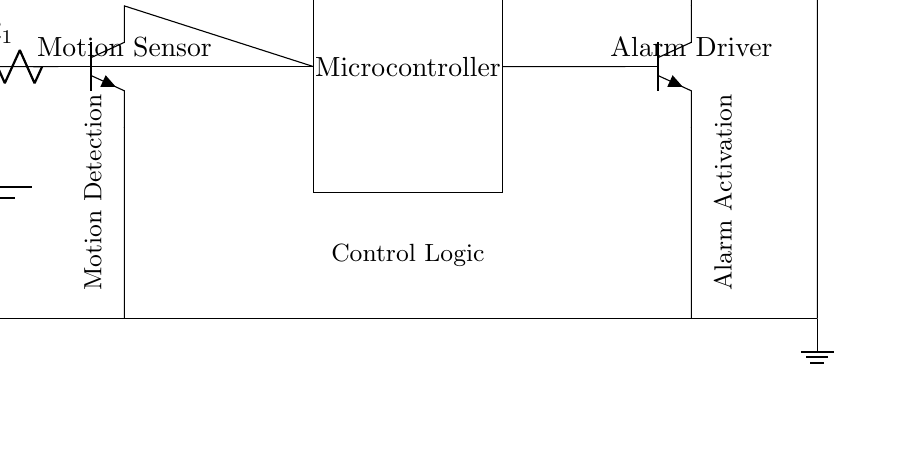What type of sensors are used in this circuit? The circuit employs a motion sensor, as indicated by the labeled component. The sensor is responsible for detecting motion in the vicinity.
Answer: Motion sensor What do the resistors in the circuit do? The resistors are denoted as components that limit the current flowing through the circuit. In this case, they help to ensure the motion sensor operates safely and effectively without drawing too much current.
Answer: Limit current What triggers the alarm in this home security system? The alarm is activated based on the output from the motion sensor. When motion is detected, it sends a signal to the microcontroller, which then activates the alarm driver to sound the buzzer.
Answer: Motion detected How is the power distributed across the components? The power from the battery is supplied to the motion sensor and microcontroller directly, indicated by the connections from the battery to these components. This design ensures all parts receive necessary power for operation.
Answer: Battery to components What role does the microcontroller play in this circuit? The microcontroller processes the input from the motion sensor. When it receives a signal indicating motion, it executes control logic to activate the alarm driver and sound the buzzer.
Answer: Processing input What type of alarm is used in this system? The circuit includes a buzzer as the alarm component, which is connected to the alarm driver that activates it when necessary.
Answer: Buzzer What is the purpose of the ground connection in the circuit? The ground connection serves as a reference point for the voltage in the circuit and provides a return path for the current. This is essential for completing the circuit and ensuring safe operation.
Answer: Reference point 